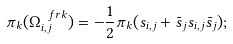Convert formula to latex. <formula><loc_0><loc_0><loc_500><loc_500>\pi _ { k } ( \Omega _ { i , j } ^ { \ f r k } ) = - \frac { 1 } { 2 } \pi _ { k } ( s _ { i , j } + \bar { s } _ { j } s _ { i , j } \bar { s } _ { j } ) ;</formula> 